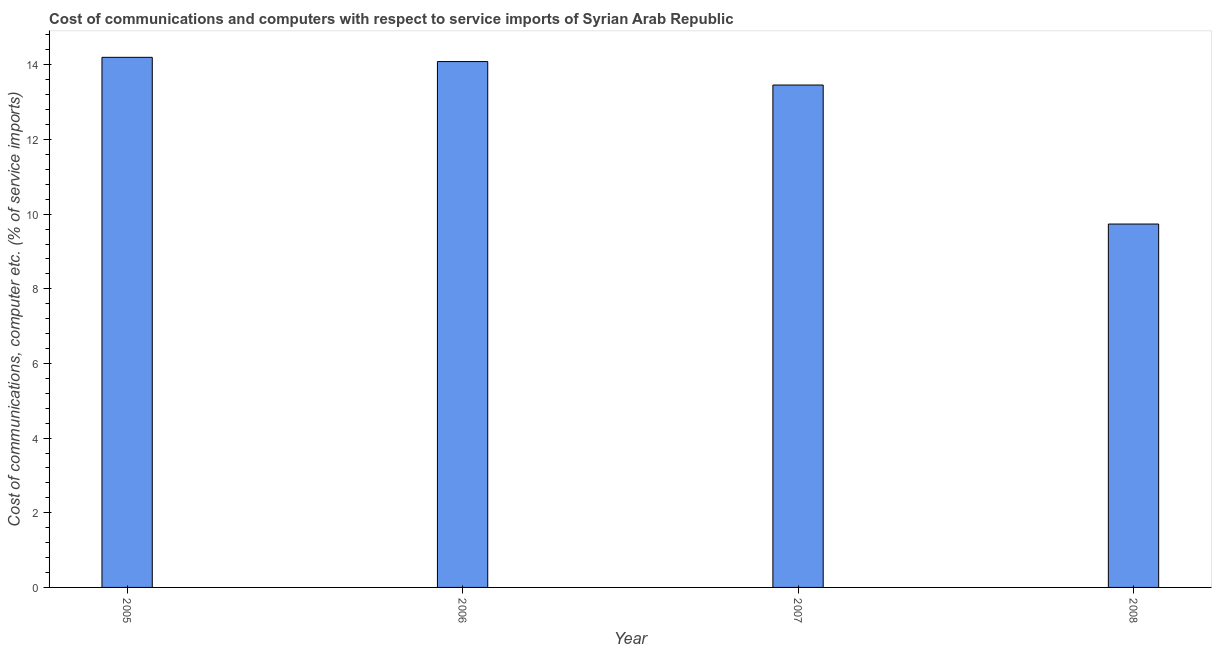Does the graph contain grids?
Keep it short and to the point. No. What is the title of the graph?
Your response must be concise. Cost of communications and computers with respect to service imports of Syrian Arab Republic. What is the label or title of the X-axis?
Provide a succinct answer. Year. What is the label or title of the Y-axis?
Give a very brief answer. Cost of communications, computer etc. (% of service imports). What is the cost of communications and computer in 2006?
Provide a succinct answer. 14.09. Across all years, what is the maximum cost of communications and computer?
Your answer should be very brief. 14.2. Across all years, what is the minimum cost of communications and computer?
Your response must be concise. 9.73. In which year was the cost of communications and computer maximum?
Provide a short and direct response. 2005. What is the sum of the cost of communications and computer?
Provide a succinct answer. 51.48. What is the difference between the cost of communications and computer in 2007 and 2008?
Your answer should be very brief. 3.72. What is the average cost of communications and computer per year?
Offer a very short reply. 12.87. What is the median cost of communications and computer?
Give a very brief answer. 13.77. What is the ratio of the cost of communications and computer in 2006 to that in 2007?
Your answer should be compact. 1.05. Is the cost of communications and computer in 2006 less than that in 2008?
Offer a very short reply. No. Is the difference between the cost of communications and computer in 2005 and 2007 greater than the difference between any two years?
Your answer should be very brief. No. What is the difference between the highest and the second highest cost of communications and computer?
Your answer should be very brief. 0.11. What is the difference between the highest and the lowest cost of communications and computer?
Your answer should be compact. 4.47. How many bars are there?
Offer a very short reply. 4. Are all the bars in the graph horizontal?
Provide a short and direct response. No. How many years are there in the graph?
Your answer should be compact. 4. What is the difference between two consecutive major ticks on the Y-axis?
Make the answer very short. 2. What is the Cost of communications, computer etc. (% of service imports) in 2005?
Ensure brevity in your answer.  14.2. What is the Cost of communications, computer etc. (% of service imports) of 2006?
Offer a very short reply. 14.09. What is the Cost of communications, computer etc. (% of service imports) of 2007?
Your answer should be compact. 13.46. What is the Cost of communications, computer etc. (% of service imports) in 2008?
Your response must be concise. 9.73. What is the difference between the Cost of communications, computer etc. (% of service imports) in 2005 and 2006?
Offer a very short reply. 0.11. What is the difference between the Cost of communications, computer etc. (% of service imports) in 2005 and 2007?
Make the answer very short. 0.74. What is the difference between the Cost of communications, computer etc. (% of service imports) in 2005 and 2008?
Your response must be concise. 4.47. What is the difference between the Cost of communications, computer etc. (% of service imports) in 2006 and 2007?
Give a very brief answer. 0.63. What is the difference between the Cost of communications, computer etc. (% of service imports) in 2006 and 2008?
Provide a short and direct response. 4.35. What is the difference between the Cost of communications, computer etc. (% of service imports) in 2007 and 2008?
Make the answer very short. 3.72. What is the ratio of the Cost of communications, computer etc. (% of service imports) in 2005 to that in 2007?
Provide a short and direct response. 1.05. What is the ratio of the Cost of communications, computer etc. (% of service imports) in 2005 to that in 2008?
Give a very brief answer. 1.46. What is the ratio of the Cost of communications, computer etc. (% of service imports) in 2006 to that in 2007?
Provide a short and direct response. 1.05. What is the ratio of the Cost of communications, computer etc. (% of service imports) in 2006 to that in 2008?
Your answer should be compact. 1.45. What is the ratio of the Cost of communications, computer etc. (% of service imports) in 2007 to that in 2008?
Give a very brief answer. 1.38. 